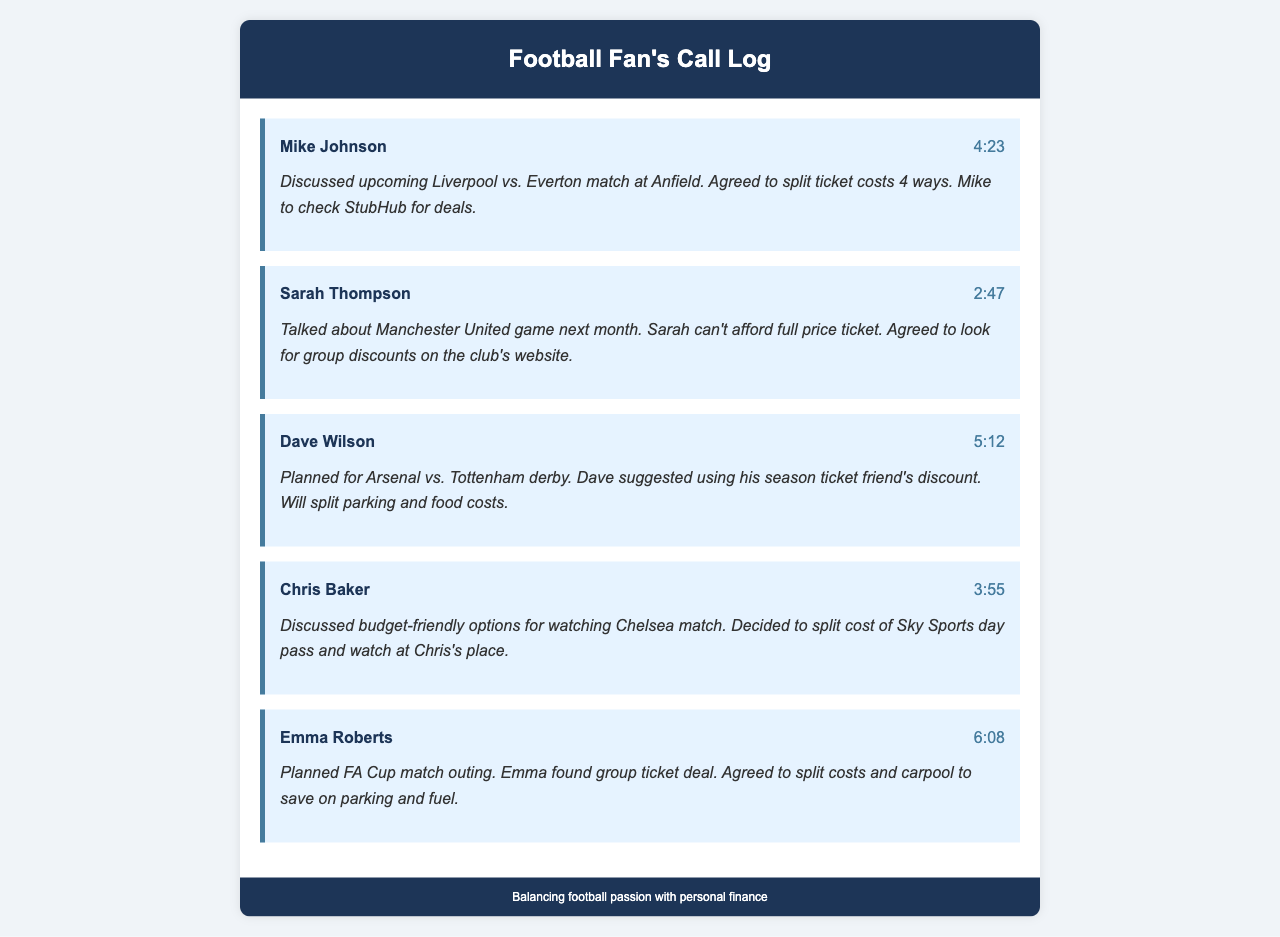What is Mike Johnson's call duration? The duration of the call with Mike Johnson is stated in the document as 4 minutes and 23 seconds.
Answer: 4:23 Who discussed the Arsenal vs. Tottenham derby? The document mentions that Dave Wilson is the person who planned for the Arsenal vs. Tottenham derby.
Answer: Dave Wilson What match was discussed with Sarah Thompson? The summary of the call with Sarah Thompson indicates that they talked about a Manchester United game.
Answer: Manchester United How much time was spent discussing the Chelsea match with Chris Baker? The call duration with Chris Baker is listed as 3 minutes and 55 seconds in the document.
Answer: 3:55 Which contact found a group ticket deal for the FA Cup match? Emma Roberts is noted in the document as the one who found a group ticket deal for the FA Cup match.
Answer: Emma Roberts What method did Emma suggest to save on costs? Emma Roberts suggested carpooling to save on parking and fuel for the FA Cup match outing.
Answer: Carpool How many ways did Mike Johnson agree to split the ticket costs? Mike Johnson agreed to split the ticket costs 4 ways for the upcoming Liverpool vs. Everton match.
Answer: 4 ways What was the approach discussed with Chris Baker about viewing the Chelsea match? The call with Chris Baker discussed splitting the cost of a Sky Sports day pass to watch the Chelsea match.
Answer: Split cost of Sky Sports day pass Which friend’s discount did Dave suggest using for the derby? Dave suggested using his season ticket friend's discount for the Arsenal vs. Tottenham derby.
Answer: Season ticket friend's discount 